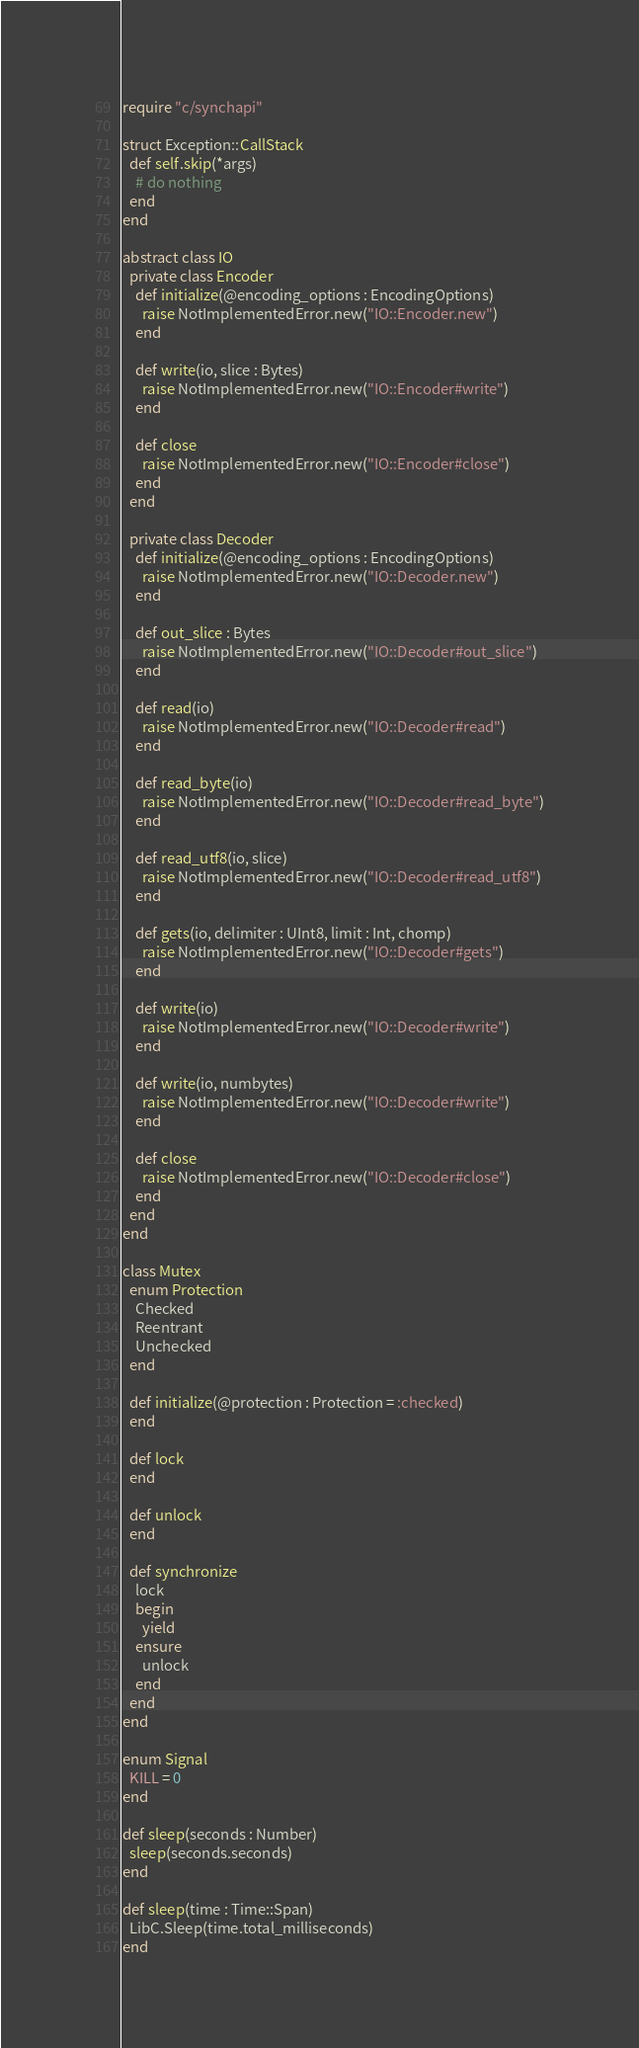Convert code to text. <code><loc_0><loc_0><loc_500><loc_500><_Crystal_>require "c/synchapi"

struct Exception::CallStack
  def self.skip(*args)
    # do nothing
  end
end

abstract class IO
  private class Encoder
    def initialize(@encoding_options : EncodingOptions)
      raise NotImplementedError.new("IO::Encoder.new")
    end

    def write(io, slice : Bytes)
      raise NotImplementedError.new("IO::Encoder#write")
    end

    def close
      raise NotImplementedError.new("IO::Encoder#close")
    end
  end

  private class Decoder
    def initialize(@encoding_options : EncodingOptions)
      raise NotImplementedError.new("IO::Decoder.new")
    end

    def out_slice : Bytes
      raise NotImplementedError.new("IO::Decoder#out_slice")
    end

    def read(io)
      raise NotImplementedError.new("IO::Decoder#read")
    end

    def read_byte(io)
      raise NotImplementedError.new("IO::Decoder#read_byte")
    end

    def read_utf8(io, slice)
      raise NotImplementedError.new("IO::Decoder#read_utf8")
    end

    def gets(io, delimiter : UInt8, limit : Int, chomp)
      raise NotImplementedError.new("IO::Decoder#gets")
    end

    def write(io)
      raise NotImplementedError.new("IO::Decoder#write")
    end

    def write(io, numbytes)
      raise NotImplementedError.new("IO::Decoder#write")
    end

    def close
      raise NotImplementedError.new("IO::Decoder#close")
    end
  end
end

class Mutex
  enum Protection
    Checked
    Reentrant
    Unchecked
  end

  def initialize(@protection : Protection = :checked)
  end

  def lock
  end

  def unlock
  end

  def synchronize
    lock
    begin
      yield
    ensure
      unlock
    end
  end
end

enum Signal
  KILL = 0
end

def sleep(seconds : Number)
  sleep(seconds.seconds)
end

def sleep(time : Time::Span)
  LibC.Sleep(time.total_milliseconds)
end
</code> 